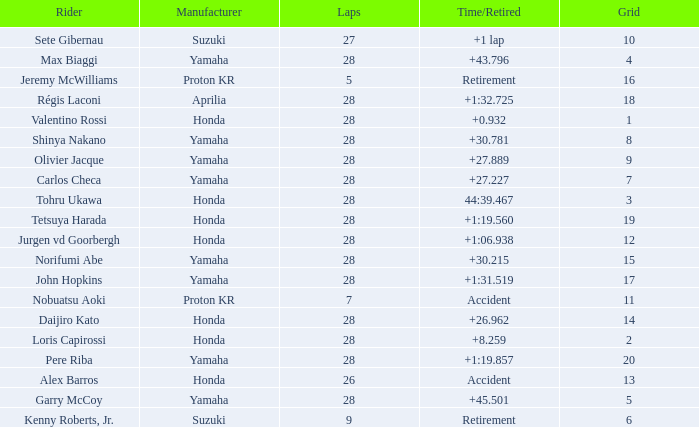How many laps did pere riba ride? 28.0. 